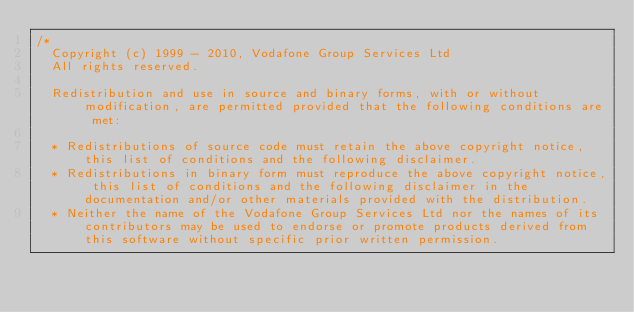<code> <loc_0><loc_0><loc_500><loc_500><_ObjectiveC_>/*
  Copyright (c) 1999 - 2010, Vodafone Group Services Ltd
  All rights reserved.

  Redistribution and use in source and binary forms, with or without modification, are permitted provided that the following conditions are met:

  * Redistributions of source code must retain the above copyright notice, this list of conditions and the following disclaimer.
  * Redistributions in binary form must reproduce the above copyright notice, this list of conditions and the following disclaimer in the documentation and/or other materials provided with the distribution.
  * Neither the name of the Vodafone Group Services Ltd nor the names of its contributors may be used to endorse or promote products derived from this software without specific prior written permission.
</code> 